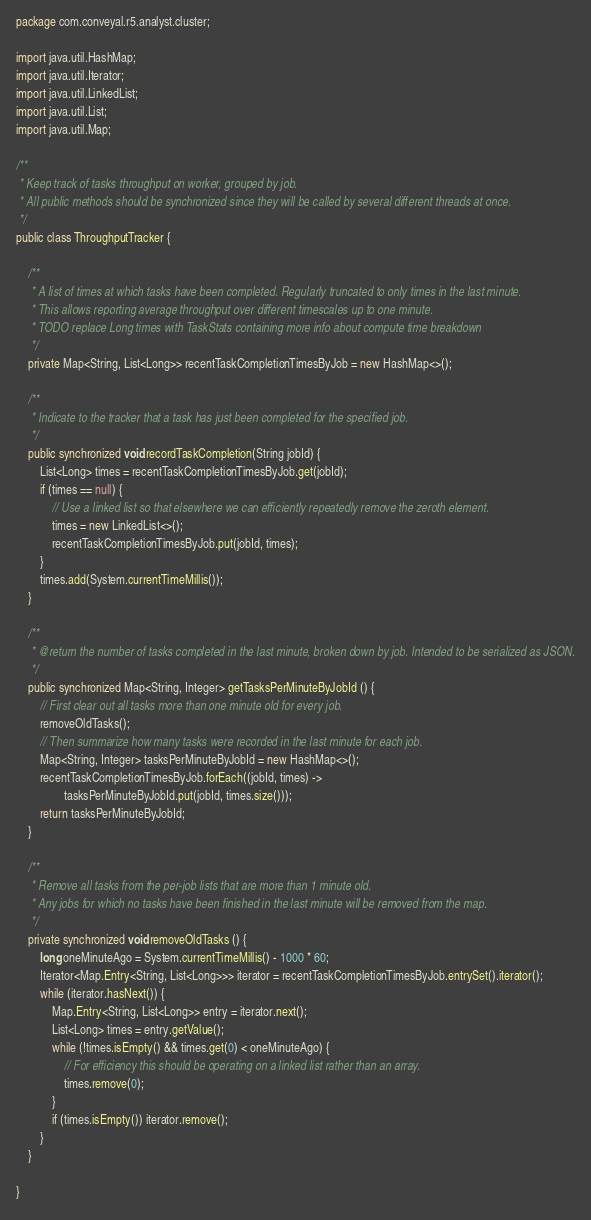Convert code to text. <code><loc_0><loc_0><loc_500><loc_500><_Java_>package com.conveyal.r5.analyst.cluster;

import java.util.HashMap;
import java.util.Iterator;
import java.util.LinkedList;
import java.util.List;
import java.util.Map;

/**
 * Keep track of tasks throughput on worker, grouped by job.
 * All public methods should be synchronized since they will be called by several different threads at once.
 */
public class ThroughputTracker {

    /**
     * A list of times at which tasks have been completed. Regularly truncated to only times in the last minute.
     * This allows reporting average throughput over different timescales up to one minute.
     * TODO replace Long times with TaskStats containing more info about compute time breakdown
     */
    private Map<String, List<Long>> recentTaskCompletionTimesByJob = new HashMap<>();

    /**
     * Indicate to the tracker that a task has just been completed for the specified job.
     */
    public synchronized void recordTaskCompletion(String jobId) {
        List<Long> times = recentTaskCompletionTimesByJob.get(jobId);
        if (times == null) {
            // Use a linked list so that elsewhere we can efficiently repeatedly remove the zeroth element.
            times = new LinkedList<>();
            recentTaskCompletionTimesByJob.put(jobId, times);
        }
        times.add(System.currentTimeMillis());
    }

    /**
     * @return the number of tasks completed in the last minute, broken down by job. Intended to be serialized as JSON.
     */
    public synchronized Map<String, Integer> getTasksPerMinuteByJobId () {
        // First clear out all tasks more than one minute old for every job.
        removeOldTasks();
        // Then summarize how many tasks were recorded in the last minute for each job.
        Map<String, Integer> tasksPerMinuteByJobId = new HashMap<>();
        recentTaskCompletionTimesByJob.forEach((jobId, times) ->
                tasksPerMinuteByJobId.put(jobId, times.size()));
        return tasksPerMinuteByJobId;
    }

    /**
     * Remove all tasks from the per-job lists that are more than 1 minute old.
     * Any jobs for which no tasks have been finished in the last minute will be removed from the map.
     */
    private synchronized void removeOldTasks () {
        long oneMinuteAgo = System.currentTimeMillis() - 1000 * 60;
        Iterator<Map.Entry<String, List<Long>>> iterator = recentTaskCompletionTimesByJob.entrySet().iterator();
        while (iterator.hasNext()) {
            Map.Entry<String, List<Long>> entry = iterator.next();
            List<Long> times = entry.getValue();
            while (!times.isEmpty() && times.get(0) < oneMinuteAgo) {
                // For efficiency this should be operating on a linked list rather than an array.
                times.remove(0);
            }
            if (times.isEmpty()) iterator.remove();
        }
    }

}
</code> 